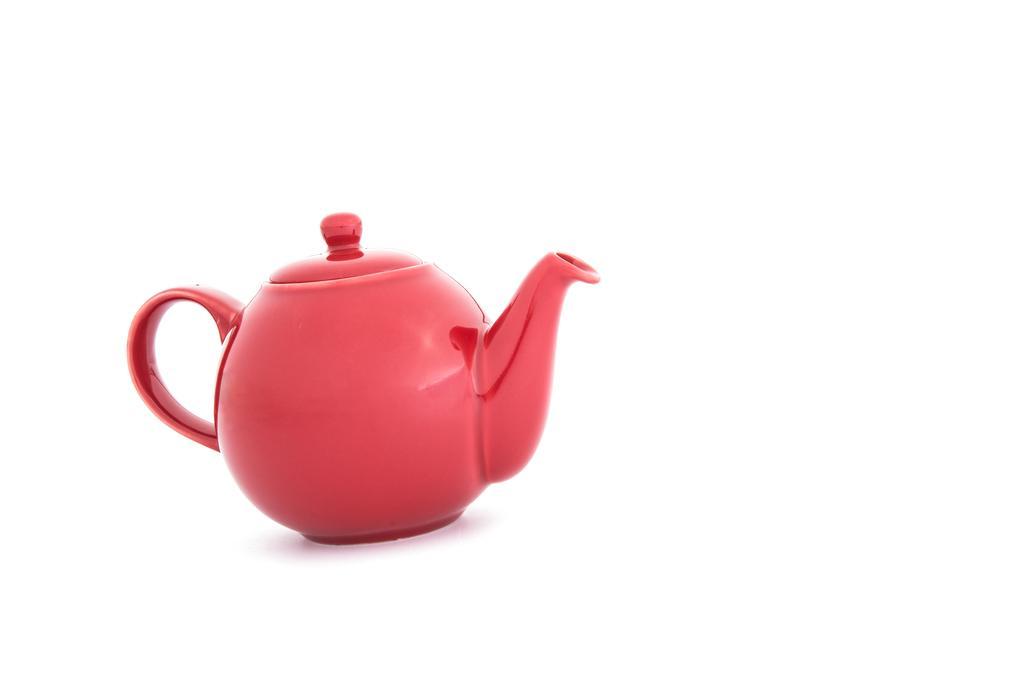Could you give a brief overview of what you see in this image? In this image we can see red color kettle is kept on the white color surface. The background of the image is in white color. 